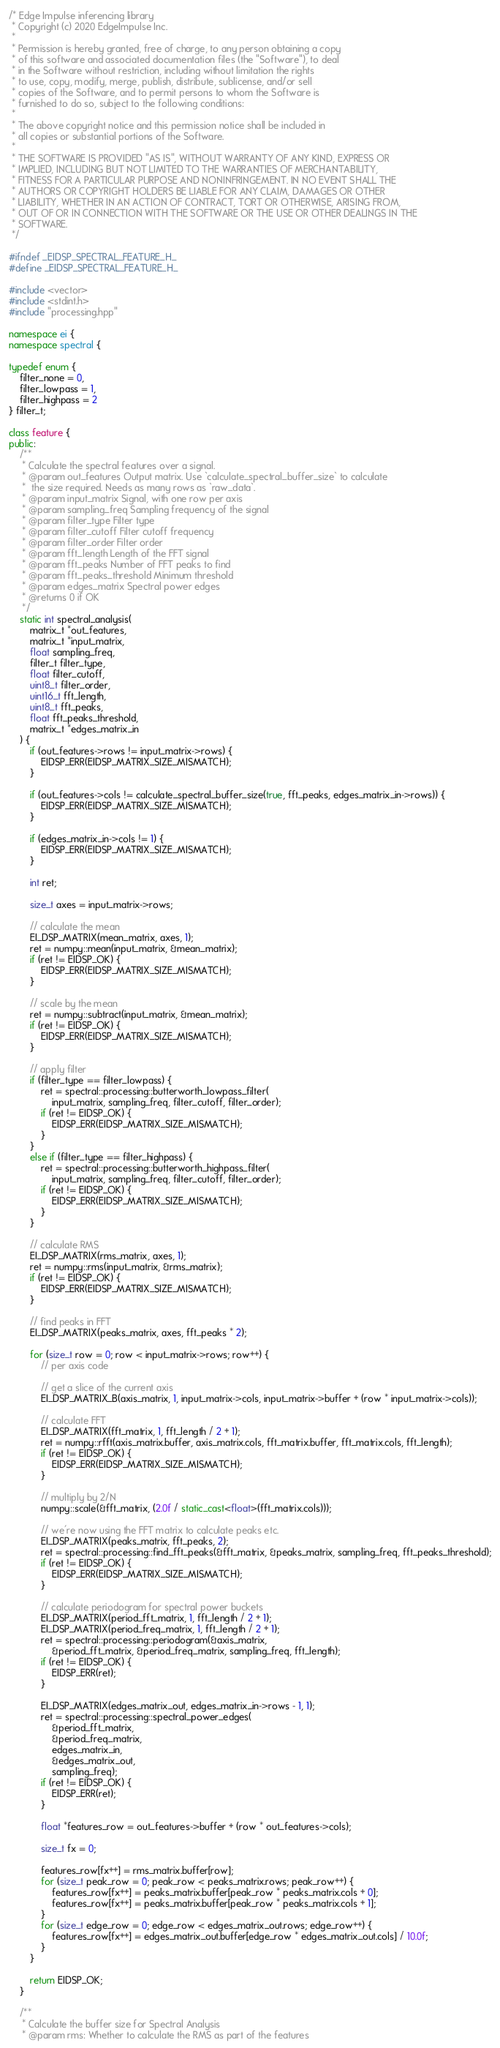<code> <loc_0><loc_0><loc_500><loc_500><_C++_>/* Edge Impulse inferencing library
 * Copyright (c) 2020 EdgeImpulse Inc.
 *
 * Permission is hereby granted, free of charge, to any person obtaining a copy
 * of this software and associated documentation files (the "Software"), to deal
 * in the Software without restriction, including without limitation the rights
 * to use, copy, modify, merge, publish, distribute, sublicense, and/or sell
 * copies of the Software, and to permit persons to whom the Software is
 * furnished to do so, subject to the following conditions:
 *
 * The above copyright notice and this permission notice shall be included in
 * all copies or substantial portions of the Software.
 *
 * THE SOFTWARE IS PROVIDED "AS IS", WITHOUT WARRANTY OF ANY KIND, EXPRESS OR
 * IMPLIED, INCLUDING BUT NOT LIMITED TO THE WARRANTIES OF MERCHANTABILITY,
 * FITNESS FOR A PARTICULAR PURPOSE AND NONINFRINGEMENT. IN NO EVENT SHALL THE
 * AUTHORS OR COPYRIGHT HOLDERS BE LIABLE FOR ANY CLAIM, DAMAGES OR OTHER
 * LIABILITY, WHETHER IN AN ACTION OF CONTRACT, TORT OR OTHERWISE, ARISING FROM,
 * OUT OF OR IN CONNECTION WITH THE SOFTWARE OR THE USE OR OTHER DEALINGS IN THE
 * SOFTWARE.
 */

#ifndef _EIDSP_SPECTRAL_FEATURE_H_
#define _EIDSP_SPECTRAL_FEATURE_H_

#include <vector>
#include <stdint.h>
#include "processing.hpp"

namespace ei {
namespace spectral {

typedef enum {
    filter_none = 0,
    filter_lowpass = 1,
    filter_highpass = 2
} filter_t;

class feature {
public:
    /**
     * Calculate the spectral features over a signal.
     * @param out_features Output matrix. Use `calculate_spectral_buffer_size` to calculate
     *  the size required. Needs as many rows as `raw_data`.
     * @param input_matrix Signal, with one row per axis
     * @param sampling_freq Sampling frequency of the signal
     * @param filter_type Filter type
     * @param filter_cutoff Filter cutoff frequency
     * @param filter_order Filter order
     * @param fft_length Length of the FFT signal
     * @param fft_peaks Number of FFT peaks to find
     * @param fft_peaks_threshold Minimum threshold
     * @param edges_matrix Spectral power edges
     * @returns 0 if OK
     */
    static int spectral_analysis(
        matrix_t *out_features,
        matrix_t *input_matrix,
        float sampling_freq,
        filter_t filter_type,
        float filter_cutoff,
        uint8_t filter_order,
        uint16_t fft_length,
        uint8_t fft_peaks,
        float fft_peaks_threshold,
        matrix_t *edges_matrix_in
    ) {
        if (out_features->rows != input_matrix->rows) {
            EIDSP_ERR(EIDSP_MATRIX_SIZE_MISMATCH);
        }

        if (out_features->cols != calculate_spectral_buffer_size(true, fft_peaks, edges_matrix_in->rows)) {
            EIDSP_ERR(EIDSP_MATRIX_SIZE_MISMATCH);
        }

        if (edges_matrix_in->cols != 1) {
            EIDSP_ERR(EIDSP_MATRIX_SIZE_MISMATCH);
        }

        int ret;

        size_t axes = input_matrix->rows;

        // calculate the mean
        EI_DSP_MATRIX(mean_matrix, axes, 1);
        ret = numpy::mean(input_matrix, &mean_matrix);
        if (ret != EIDSP_OK) {
            EIDSP_ERR(EIDSP_MATRIX_SIZE_MISMATCH);
        }

        // scale by the mean
        ret = numpy::subtract(input_matrix, &mean_matrix);
        if (ret != EIDSP_OK) {
            EIDSP_ERR(EIDSP_MATRIX_SIZE_MISMATCH);
        }

        // apply filter
        if (filter_type == filter_lowpass) {
            ret = spectral::processing::butterworth_lowpass_filter(
                input_matrix, sampling_freq, filter_cutoff, filter_order);
            if (ret != EIDSP_OK) {
                EIDSP_ERR(EIDSP_MATRIX_SIZE_MISMATCH);
            }
        }
        else if (filter_type == filter_highpass) {
            ret = spectral::processing::butterworth_highpass_filter(
                input_matrix, sampling_freq, filter_cutoff, filter_order);
            if (ret != EIDSP_OK) {
                EIDSP_ERR(EIDSP_MATRIX_SIZE_MISMATCH);
            }
        }

        // calculate RMS
        EI_DSP_MATRIX(rms_matrix, axes, 1);
        ret = numpy::rms(input_matrix, &rms_matrix);
        if (ret != EIDSP_OK) {
            EIDSP_ERR(EIDSP_MATRIX_SIZE_MISMATCH);
        }

        // find peaks in FFT
        EI_DSP_MATRIX(peaks_matrix, axes, fft_peaks * 2);

        for (size_t row = 0; row < input_matrix->rows; row++) {
            // per axis code

            // get a slice of the current axis
            EI_DSP_MATRIX_B(axis_matrix, 1, input_matrix->cols, input_matrix->buffer + (row * input_matrix->cols));

            // calculate FFT
            EI_DSP_MATRIX(fft_matrix, 1, fft_length / 2 + 1);
            ret = numpy::rfft(axis_matrix.buffer, axis_matrix.cols, fft_matrix.buffer, fft_matrix.cols, fft_length);
            if (ret != EIDSP_OK) {
                EIDSP_ERR(EIDSP_MATRIX_SIZE_MISMATCH);
            }

            // multiply by 2/N
            numpy::scale(&fft_matrix, (2.0f / static_cast<float>(fft_matrix.cols)));

            // we're now using the FFT matrix to calculate peaks etc.
            EI_DSP_MATRIX(peaks_matrix, fft_peaks, 2);
            ret = spectral::processing::find_fft_peaks(&fft_matrix, &peaks_matrix, sampling_freq, fft_peaks_threshold);
            if (ret != EIDSP_OK) {
                EIDSP_ERR(EIDSP_MATRIX_SIZE_MISMATCH);
            }

            // calculate periodogram for spectral power buckets
            EI_DSP_MATRIX(period_fft_matrix, 1, fft_length / 2 + 1);
            EI_DSP_MATRIX(period_freq_matrix, 1, fft_length / 2 + 1);
            ret = spectral::processing::periodogram(&axis_matrix,
                &period_fft_matrix, &period_freq_matrix, sampling_freq, fft_length);
            if (ret != EIDSP_OK) {
                EIDSP_ERR(ret);
            }

            EI_DSP_MATRIX(edges_matrix_out, edges_matrix_in->rows - 1, 1);
            ret = spectral::processing::spectral_power_edges(
                &period_fft_matrix,
                &period_freq_matrix,
                edges_matrix_in,
                &edges_matrix_out,
                sampling_freq);
            if (ret != EIDSP_OK) {
                EIDSP_ERR(ret);
            }

            float *features_row = out_features->buffer + (row * out_features->cols);

            size_t fx = 0;

            features_row[fx++] = rms_matrix.buffer[row];
            for (size_t peak_row = 0; peak_row < peaks_matrix.rows; peak_row++) {
                features_row[fx++] = peaks_matrix.buffer[peak_row * peaks_matrix.cols + 0];
                features_row[fx++] = peaks_matrix.buffer[peak_row * peaks_matrix.cols + 1];
            }
            for (size_t edge_row = 0; edge_row < edges_matrix_out.rows; edge_row++) {
                features_row[fx++] = edges_matrix_out.buffer[edge_row * edges_matrix_out.cols] / 10.0f;
            }
        }

        return EIDSP_OK;
    }

    /**
     * Calculate the buffer size for Spectral Analysis
     * @param rms: Whether to calculate the RMS as part of the features</code> 